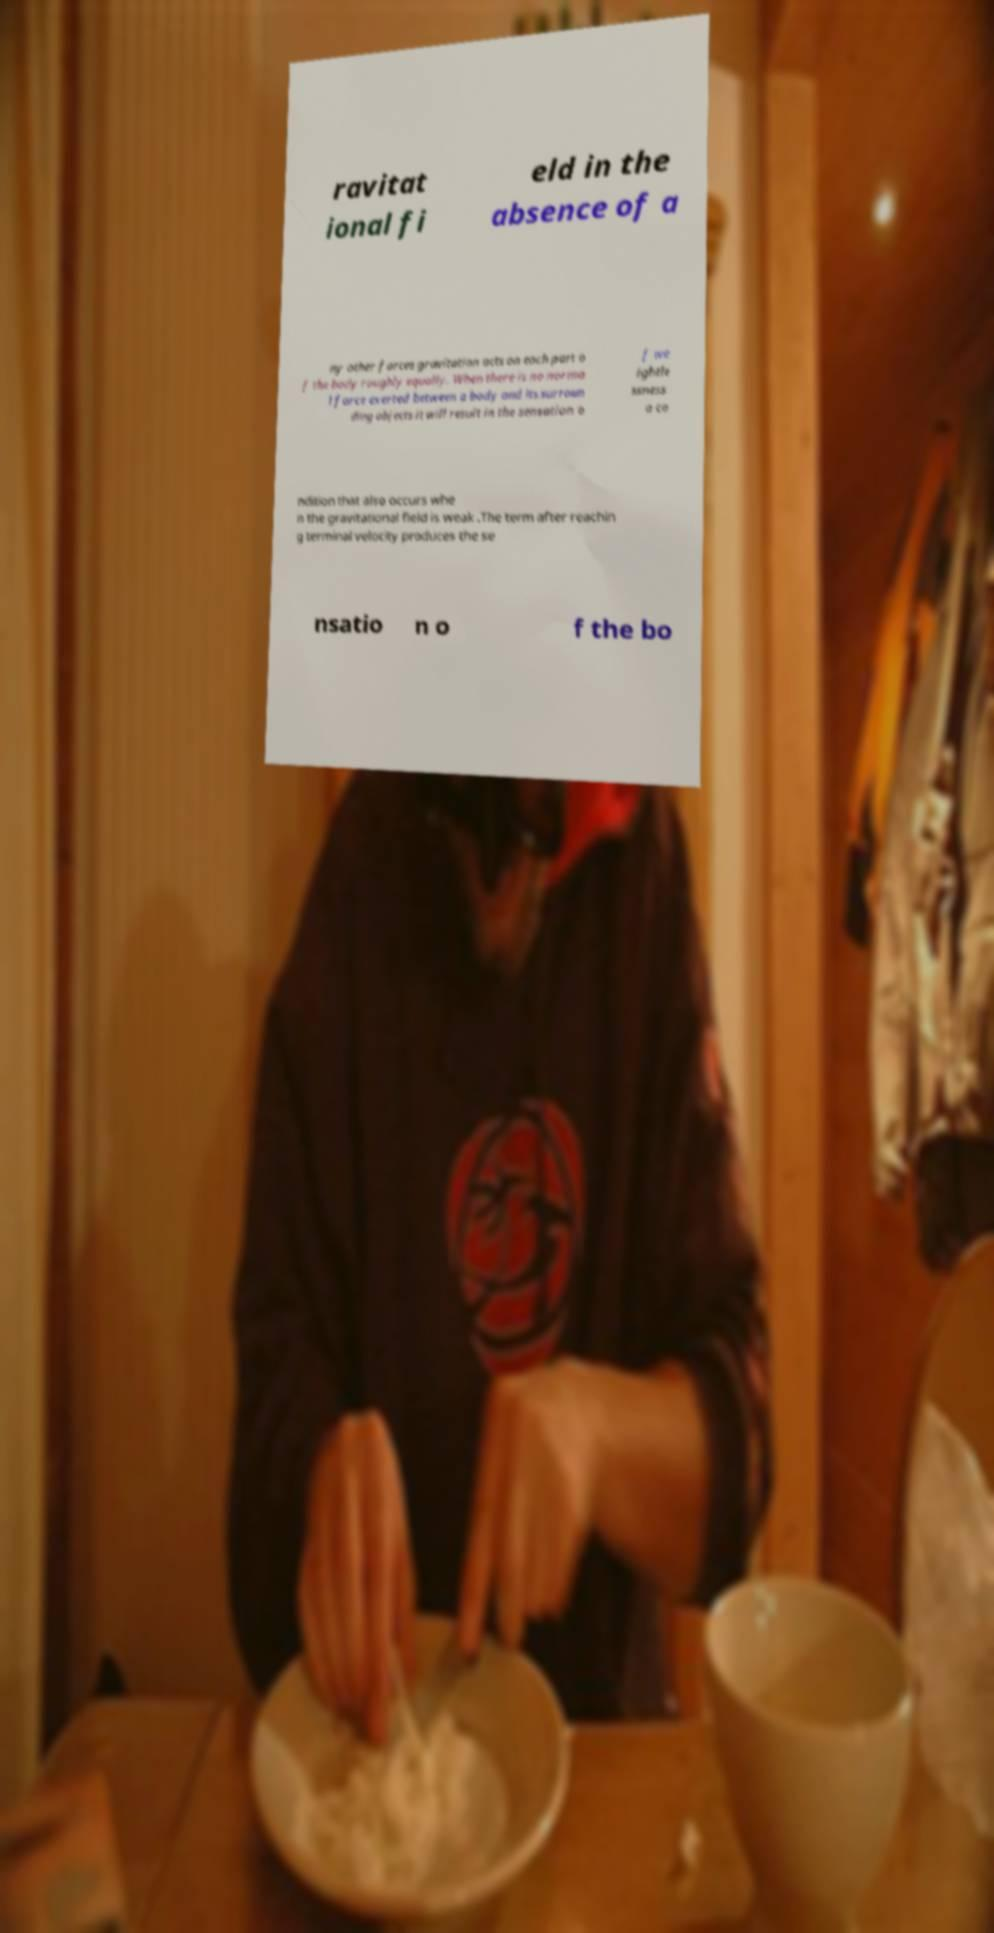What messages or text are displayed in this image? I need them in a readable, typed format. ravitat ional fi eld in the absence of a ny other forces gravitation acts on each part o f the body roughly equally. When there is no norma l force exerted between a body and its surroun ding objects it will result in the sensation o f we ightle ssness a co ndition that also occurs whe n the gravitational field is weak .The term after reachin g terminal velocity produces the se nsatio n o f the bo 